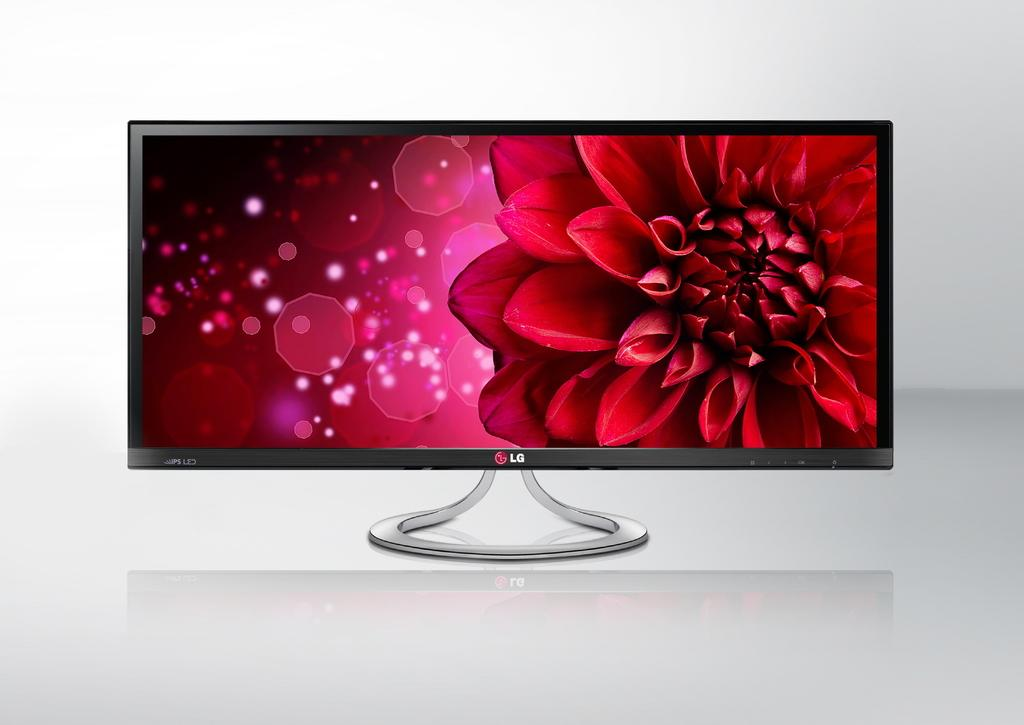What is the main object in the picture? There is a television in the picture. What is shown on the television screen? The television screen displays a flower. What can be seen behind the television? There is a wall behind the television. Who is the writer in the picture? There is no writer present in the picture; it features a television displaying a flower and a wall behind it. 